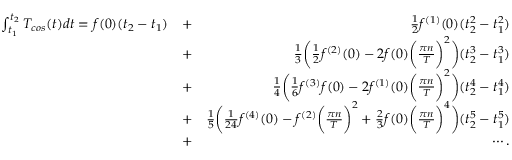<formula> <loc_0><loc_0><loc_500><loc_500>\begin{array} { r l r } { \int _ { t _ { 1 } } ^ { t _ { 2 } } T _ { \cos } ( t ) d t = f ( 0 ) ( t _ { 2 } - t _ { 1 } ) } & { + } & { \frac { 1 } { 2 } f ^ { ( 1 ) } ( 0 ) ( t _ { 2 } ^ { 2 } - t _ { 1 } ^ { 2 } ) } \\ & { + } & { \frac { 1 } { 3 } \left ( \frac { 1 } { 2 } f ^ { ( 2 ) } ( 0 ) - 2 f ( 0 ) \left ( \frac { \pi n } { T } \right ) ^ { 2 } \right ) ( t _ { 2 } ^ { 3 } - t _ { 1 } ^ { 3 } ) } \\ & { + } & { \frac { 1 } { 4 } \left ( \frac { 1 } { 6 } f ^ { ( 3 ) } f ( 0 ) - 2 f ^ { ( 1 ) } ( 0 ) \left ( \frac { \pi n } { T } \right ) ^ { 2 } \right ) ( t _ { 2 } ^ { 4 } - t _ { 1 } ^ { 4 } ) } \\ & { + } & { \frac { 1 } { 5 } \left ( \frac { 1 } { 2 4 } f ^ { ( 4 ) } ( 0 ) - f ^ { ( 2 ) } \left ( \frac { \pi n } { T } \right ) ^ { 2 } + \frac { 2 } { 3 } f ( 0 ) \left ( \frac { \pi n } { T } \right ) ^ { 4 } \right ) ( t _ { 2 } ^ { 5 } - t _ { 1 } ^ { 5 } ) } \\ & { + } & { \cdots . } \end{array}</formula> 